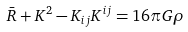Convert formula to latex. <formula><loc_0><loc_0><loc_500><loc_500>\bar { R } + K ^ { 2 } - K _ { i j } K ^ { i j } = 1 6 \pi G \rho</formula> 